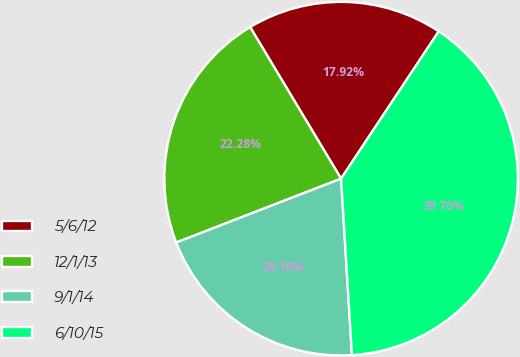<chart> <loc_0><loc_0><loc_500><loc_500><pie_chart><fcel>5/6/12<fcel>12/1/13<fcel>9/1/14<fcel>6/10/15<nl><fcel>17.92%<fcel>22.28%<fcel>20.1%<fcel>39.7%<nl></chart> 